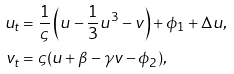Convert formula to latex. <formula><loc_0><loc_0><loc_500><loc_500>u _ { t } & = \frac { 1 } { \varsigma } \left ( u - \frac { 1 } { 3 } u ^ { 3 } - v \right ) + \phi _ { 1 } + \Delta u , \\ v _ { t } & = \varsigma ( u + \beta - \gamma v - \phi _ { 2 } ) ,</formula> 